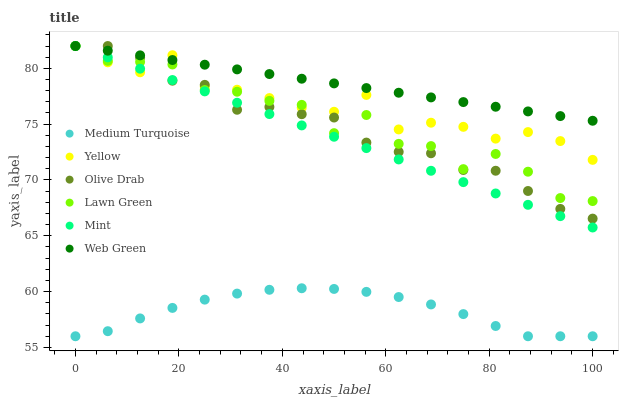Does Medium Turquoise have the minimum area under the curve?
Answer yes or no. Yes. Does Web Green have the maximum area under the curve?
Answer yes or no. Yes. Does Yellow have the minimum area under the curve?
Answer yes or no. No. Does Yellow have the maximum area under the curve?
Answer yes or no. No. Is Web Green the smoothest?
Answer yes or no. Yes. Is Lawn Green the roughest?
Answer yes or no. Yes. Is Yellow the smoothest?
Answer yes or no. No. Is Yellow the roughest?
Answer yes or no. No. Does Medium Turquoise have the lowest value?
Answer yes or no. Yes. Does Yellow have the lowest value?
Answer yes or no. No. Does Olive Drab have the highest value?
Answer yes or no. Yes. Does Medium Turquoise have the highest value?
Answer yes or no. No. Is Medium Turquoise less than Olive Drab?
Answer yes or no. Yes. Is Yellow greater than Medium Turquoise?
Answer yes or no. Yes. Does Lawn Green intersect Yellow?
Answer yes or no. Yes. Is Lawn Green less than Yellow?
Answer yes or no. No. Is Lawn Green greater than Yellow?
Answer yes or no. No. Does Medium Turquoise intersect Olive Drab?
Answer yes or no. No. 